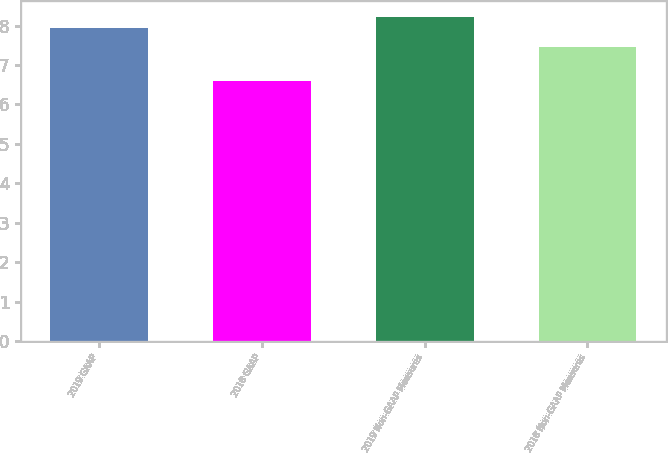Convert chart. <chart><loc_0><loc_0><loc_500><loc_500><bar_chart><fcel>2019 GAAP<fcel>2018 GAAP<fcel>2019 Non-GAAP Measures<fcel>2018 Non-GAAP Measures<nl><fcel>7.94<fcel>6.59<fcel>8.21<fcel>7.45<nl></chart> 